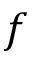Convert formula to latex. <formula><loc_0><loc_0><loc_500><loc_500>f</formula> 